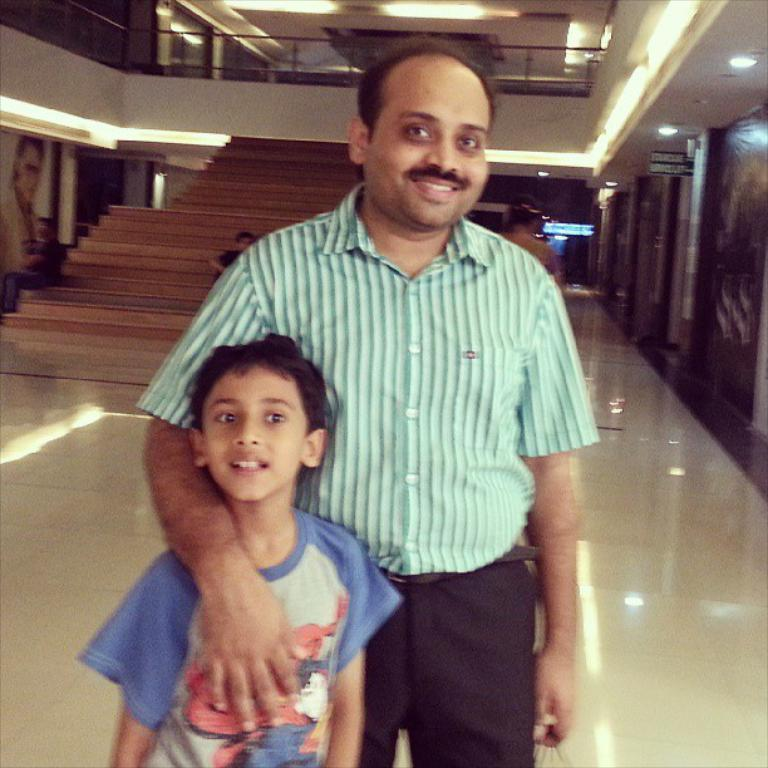How many people are in the image? There are two persons standing in the image. What is the surface on which the persons are standing? The persons are standing on the ground. What can be seen in the background of the image? There is a wall and lights visible in the background of the image. What is the condition of the bite mark on the person's arm in the image? There is no bite mark visible on any person's arm in the image. 